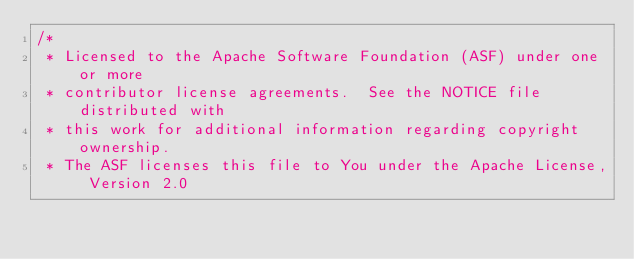Convert code to text. <code><loc_0><loc_0><loc_500><loc_500><_Java_>/*
 * Licensed to the Apache Software Foundation (ASF) under one or more
 * contributor license agreements.  See the NOTICE file distributed with
 * this work for additional information regarding copyright ownership.
 * The ASF licenses this file to You under the Apache License, Version 2.0</code> 